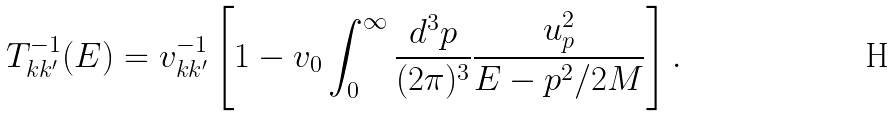<formula> <loc_0><loc_0><loc_500><loc_500>T _ { k k ^ { \prime } } ^ { - 1 } ( E ) = v _ { k k ^ { \prime } } ^ { - 1 } \left [ 1 - v _ { 0 } \int _ { 0 } ^ { \infty } \frac { d ^ { 3 } p } { ( 2 \pi ) ^ { 3 } } \frac { u _ { p } ^ { 2 } } { E - p ^ { 2 } / 2 M } \right ] .</formula> 